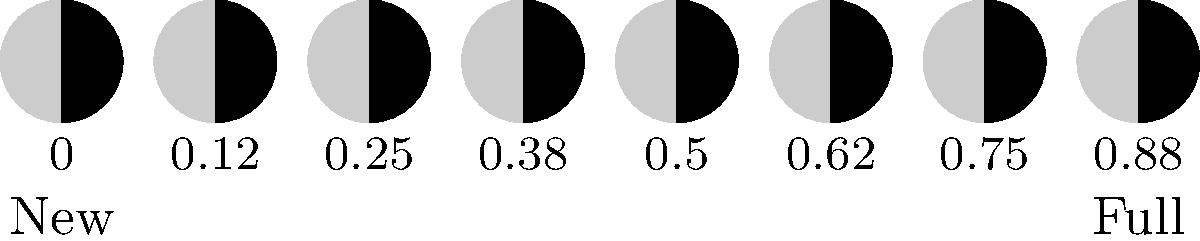In the context of lunar phases and their historical significance, consider the diagram showing the moon's appearance at different phase values. Which phase value corresponds to the First Quarter moon, a stage that has been historically important for navigation and timekeeping? To answer this question, let's break down the lunar phases and their corresponding values:

1. The diagram shows the moon's appearance from New Moon (0.00) to Full Moon (1.00), with intermediate stages.

2. The lunar cycle is divided into eight main phases, each about 3.5 days long:
   - New Moon (0.00)
   - Waxing Crescent
   - First Quarter
   - Waxing Gibbous
   - Full Moon (0.50)
   - Waning Gibbous
   - Last Quarter
   - Waning Crescent

3. The First Quarter moon occurs when half of the moon's visible surface is illuminated from our perspective on Earth.

4. In the diagram, this corresponds to the phase where exactly half of the moon is lit (right half), which is the fourth image from the left.

5. The value associated with this image is 0.25, or one-quarter of the way through the lunar cycle.

6. Historically, the First Quarter moon has been significant for navigation and timekeeping because:
   - It rises around noon and sets around midnight, making it visible in the evening sky.
   - Its distinct half-illuminated appearance made it easy to identify.
   - It occurs at regular intervals, helping to mark the passage of time.

Therefore, the phase value that corresponds to the First Quarter moon is 0.25.
Answer: 0.25 